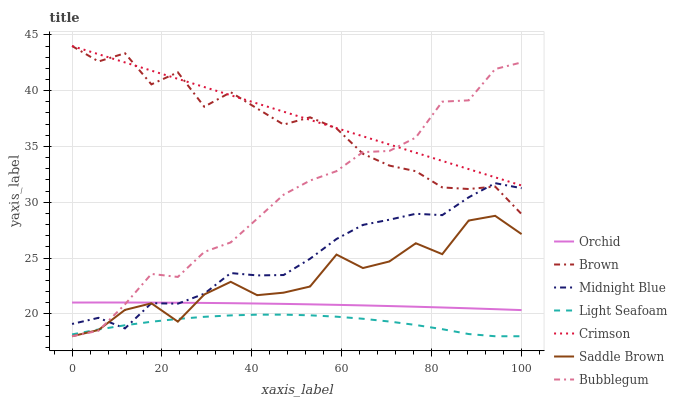Does Light Seafoam have the minimum area under the curve?
Answer yes or no. Yes. Does Crimson have the maximum area under the curve?
Answer yes or no. Yes. Does Midnight Blue have the minimum area under the curve?
Answer yes or no. No. Does Midnight Blue have the maximum area under the curve?
Answer yes or no. No. Is Crimson the smoothest?
Answer yes or no. Yes. Is Saddle Brown the roughest?
Answer yes or no. Yes. Is Midnight Blue the smoothest?
Answer yes or no. No. Is Midnight Blue the roughest?
Answer yes or no. No. Does Midnight Blue have the lowest value?
Answer yes or no. No. Does Crimson have the highest value?
Answer yes or no. Yes. Does Midnight Blue have the highest value?
Answer yes or no. No. Is Midnight Blue less than Crimson?
Answer yes or no. Yes. Is Brown greater than Light Seafoam?
Answer yes or no. Yes. Does Midnight Blue intersect Orchid?
Answer yes or no. Yes. Is Midnight Blue less than Orchid?
Answer yes or no. No. Is Midnight Blue greater than Orchid?
Answer yes or no. No. Does Midnight Blue intersect Crimson?
Answer yes or no. No. 